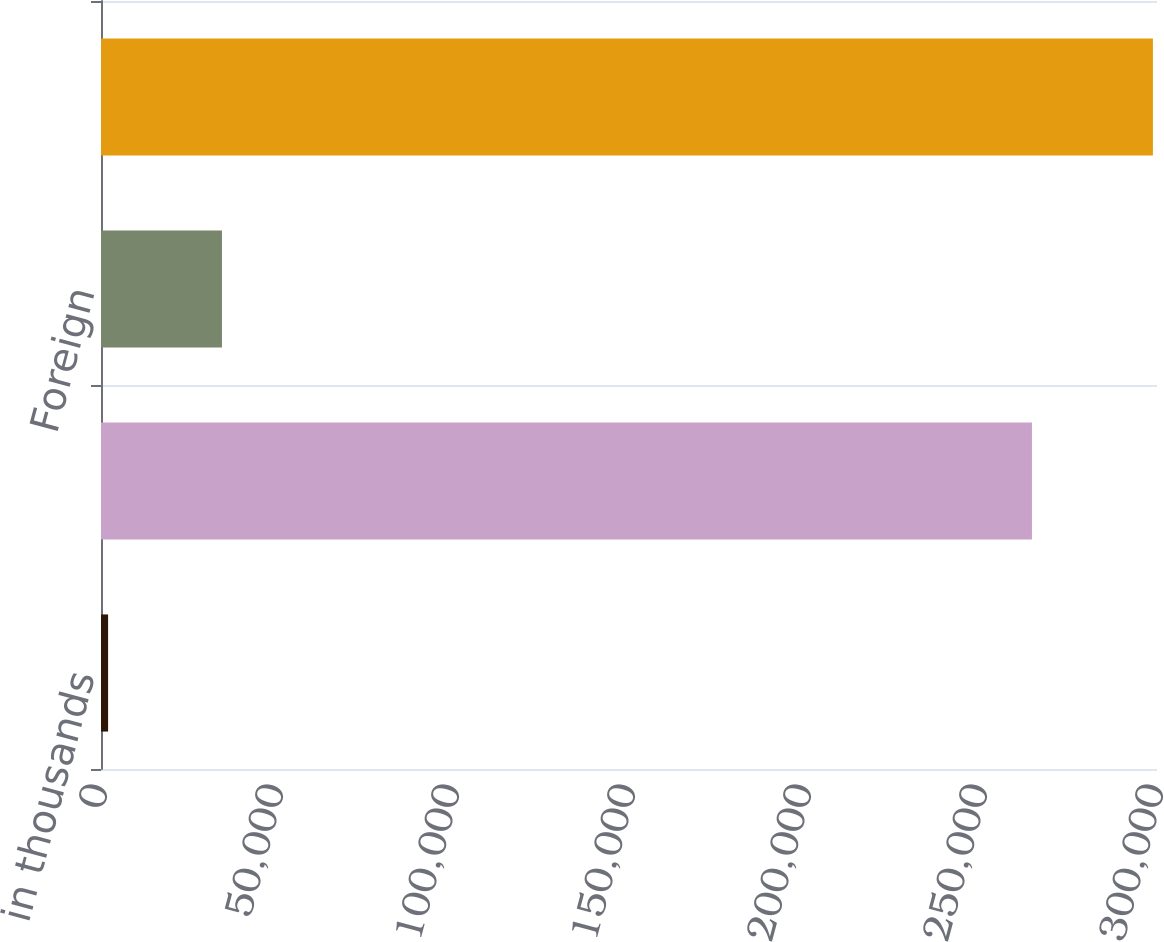Convert chart. <chart><loc_0><loc_0><loc_500><loc_500><bar_chart><fcel>in thousands<fcel>Domestic<fcel>Foreign<fcel>Total<nl><fcel>2014<fcel>264473<fcel>34365<fcel>298838<nl></chart> 